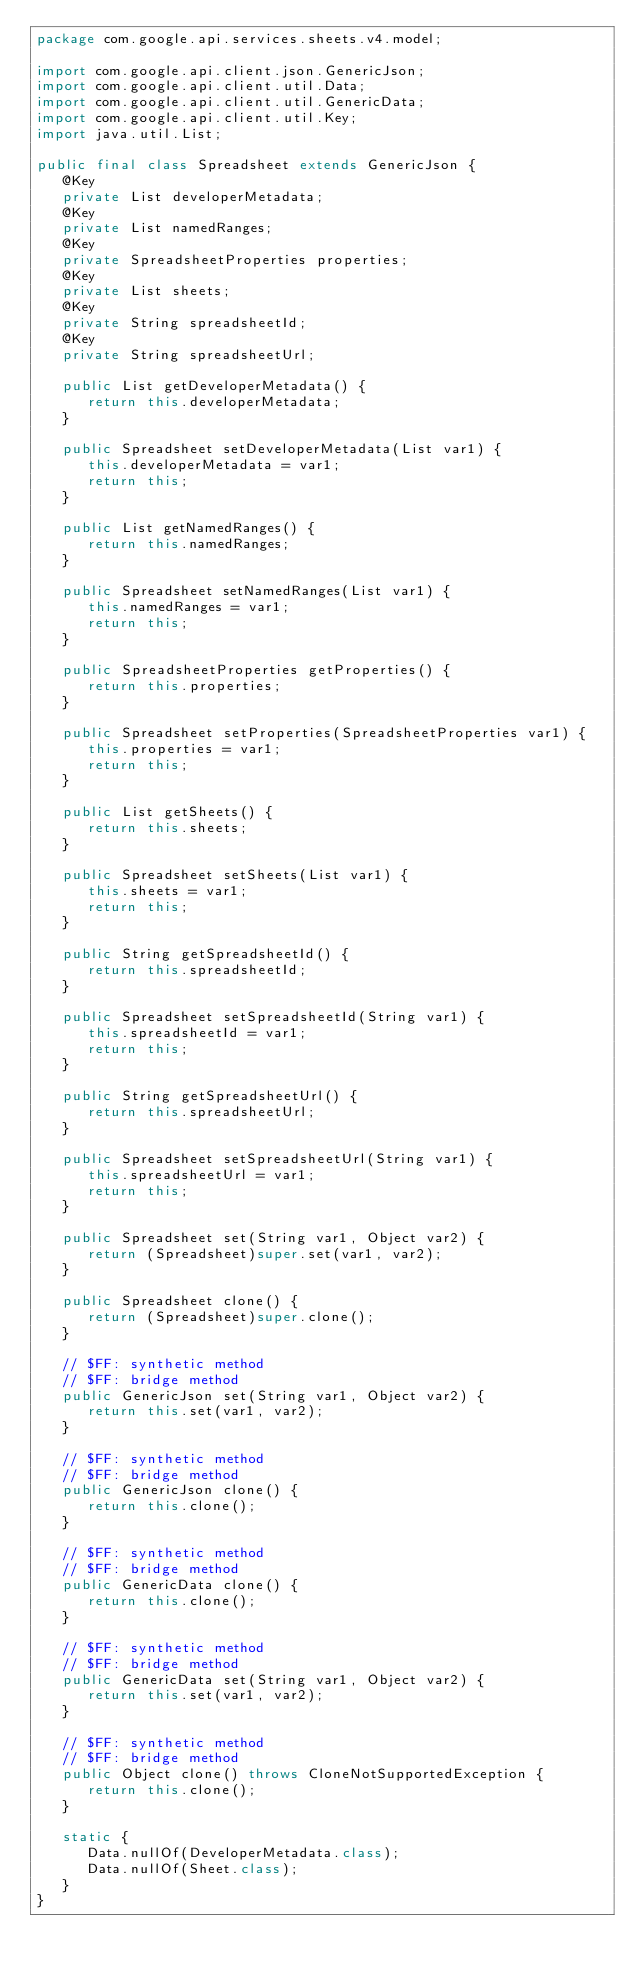<code> <loc_0><loc_0><loc_500><loc_500><_Java_>package com.google.api.services.sheets.v4.model;

import com.google.api.client.json.GenericJson;
import com.google.api.client.util.Data;
import com.google.api.client.util.GenericData;
import com.google.api.client.util.Key;
import java.util.List;

public final class Spreadsheet extends GenericJson {
   @Key
   private List developerMetadata;
   @Key
   private List namedRanges;
   @Key
   private SpreadsheetProperties properties;
   @Key
   private List sheets;
   @Key
   private String spreadsheetId;
   @Key
   private String spreadsheetUrl;

   public List getDeveloperMetadata() {
      return this.developerMetadata;
   }

   public Spreadsheet setDeveloperMetadata(List var1) {
      this.developerMetadata = var1;
      return this;
   }

   public List getNamedRanges() {
      return this.namedRanges;
   }

   public Spreadsheet setNamedRanges(List var1) {
      this.namedRanges = var1;
      return this;
   }

   public SpreadsheetProperties getProperties() {
      return this.properties;
   }

   public Spreadsheet setProperties(SpreadsheetProperties var1) {
      this.properties = var1;
      return this;
   }

   public List getSheets() {
      return this.sheets;
   }

   public Spreadsheet setSheets(List var1) {
      this.sheets = var1;
      return this;
   }

   public String getSpreadsheetId() {
      return this.spreadsheetId;
   }

   public Spreadsheet setSpreadsheetId(String var1) {
      this.spreadsheetId = var1;
      return this;
   }

   public String getSpreadsheetUrl() {
      return this.spreadsheetUrl;
   }

   public Spreadsheet setSpreadsheetUrl(String var1) {
      this.spreadsheetUrl = var1;
      return this;
   }

   public Spreadsheet set(String var1, Object var2) {
      return (Spreadsheet)super.set(var1, var2);
   }

   public Spreadsheet clone() {
      return (Spreadsheet)super.clone();
   }

   // $FF: synthetic method
   // $FF: bridge method
   public GenericJson set(String var1, Object var2) {
      return this.set(var1, var2);
   }

   // $FF: synthetic method
   // $FF: bridge method
   public GenericJson clone() {
      return this.clone();
   }

   // $FF: synthetic method
   // $FF: bridge method
   public GenericData clone() {
      return this.clone();
   }

   // $FF: synthetic method
   // $FF: bridge method
   public GenericData set(String var1, Object var2) {
      return this.set(var1, var2);
   }

   // $FF: synthetic method
   // $FF: bridge method
   public Object clone() throws CloneNotSupportedException {
      return this.clone();
   }

   static {
      Data.nullOf(DeveloperMetadata.class);
      Data.nullOf(Sheet.class);
   }
}
</code> 